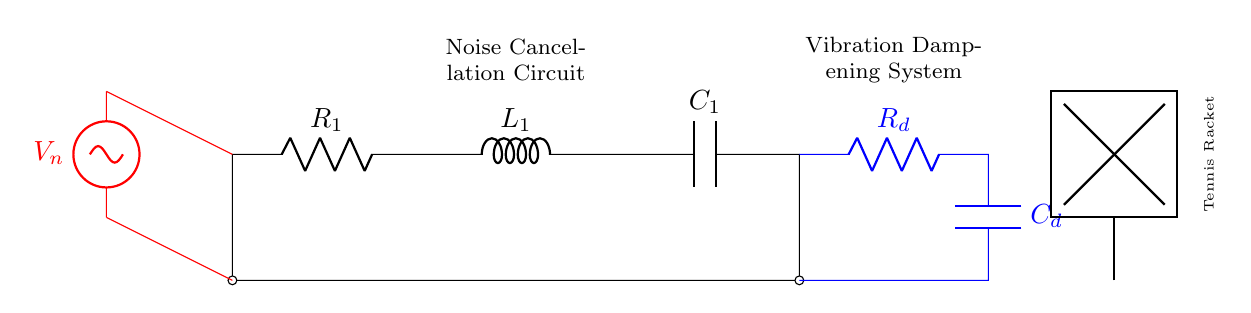What type of circuit is represented? The circuit is a noise cancellation circuit, specifically designed for vibration dampening in a tennis racket. This is inferred from the labels and the inclusion of a noise source as well as vibration dampening components.
Answer: Noise cancellation circuit What components are present in the main circuit? The main components in the circuit are a resistor, inductor, and capacitor, labeled as R1, L1, and C1 respectively. Each of these components plays a critical role in managing noise and vibrations.
Answer: Resistor, inductor, capacitor What does R_d represent? R_d is labeled as the resistor in the vibration dampening system connected at the output. This signifies its role in reducing oscillations or vibrations from the racket.
Answer: Resistor How many power sources are in the circuit? There is one power source identified, labeled as V_n, which indicates the presence of an external noise voltage affecting the circuit’s response.
Answer: One What is the purpose of the capacitor C_d? C_d is part of the dampening system and functions to filter or manage voltage fluctuations caused by vibrations, thus aiding in noise cancellation. Its specific role is to store and release energy based on the racket's movement.
Answer: Filter voltage fluctuations What type of circuit configuration is used for R1, L1, and C1? R1, L1, and C1 are connected in series, as they are all in a single path within the circuit. This means the same current flows through all components, affecting their collective response to impedance.
Answer: Series How does the noise source V_n affect the circuit? V_n, as an external noise source, introduces unwanted voltage that influences the overall function of the circuit, causing the components to react accordingly to dampen vibrations and cancel noise. This interplay is crucial for the circuit's effectiveness.
Answer: Influences circuit response 